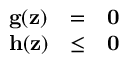<formula> <loc_0><loc_0><loc_500><loc_500>\begin{array} { l c l } { g ( z ) } & { = } & { 0 } \\ { h ( z ) } & { \leq } & { 0 } \end{array}</formula> 